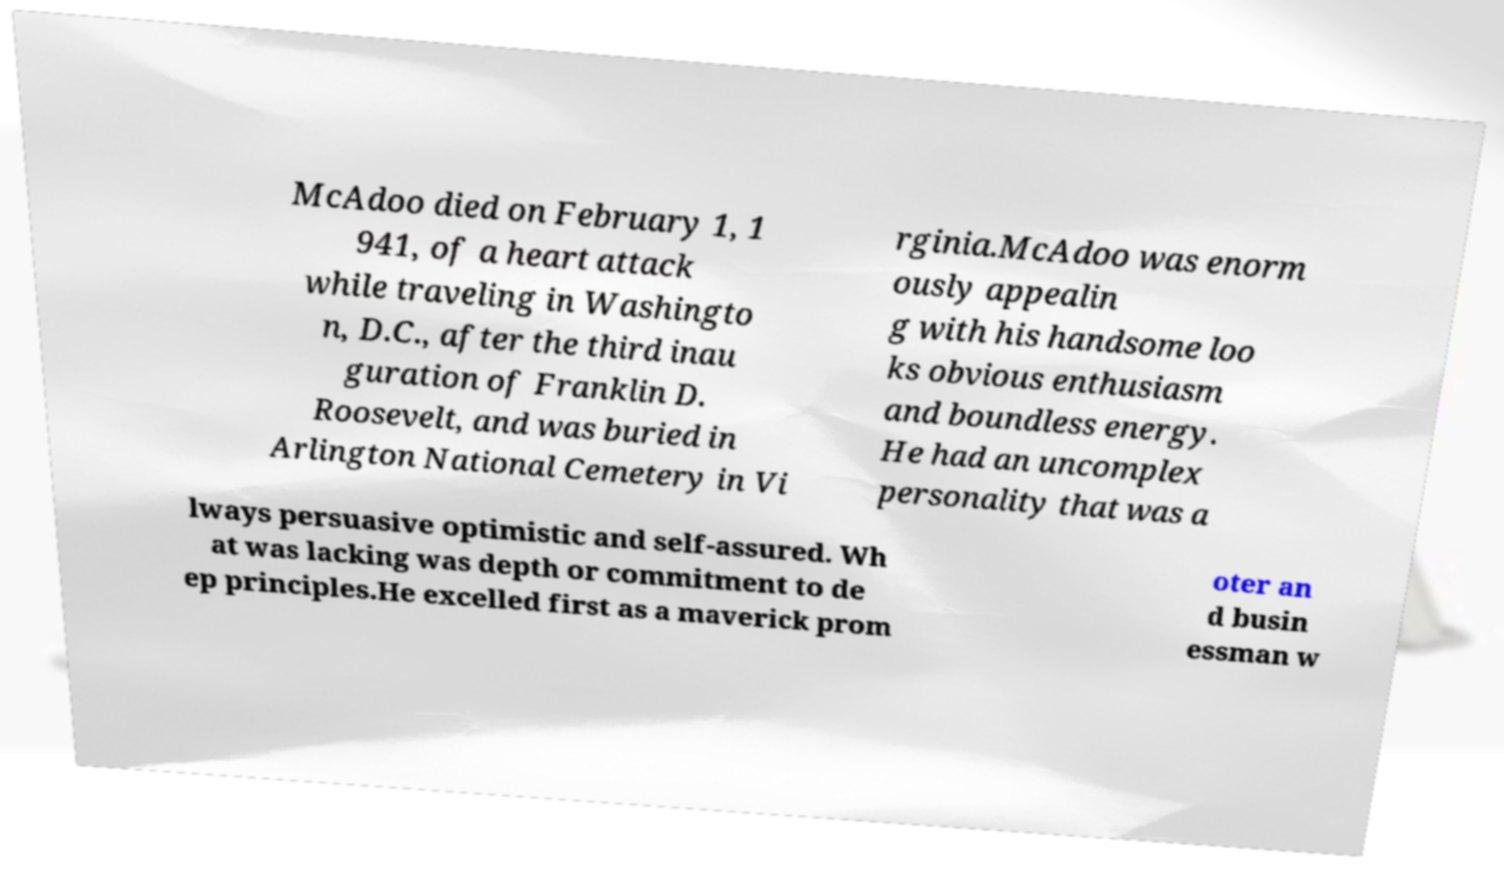Can you accurately transcribe the text from the provided image for me? McAdoo died on February 1, 1 941, of a heart attack while traveling in Washingto n, D.C., after the third inau guration of Franklin D. Roosevelt, and was buried in Arlington National Cemetery in Vi rginia.McAdoo was enorm ously appealin g with his handsome loo ks obvious enthusiasm and boundless energy. He had an uncomplex personality that was a lways persuasive optimistic and self-assured. Wh at was lacking was depth or commitment to de ep principles.He excelled first as a maverick prom oter an d busin essman w 